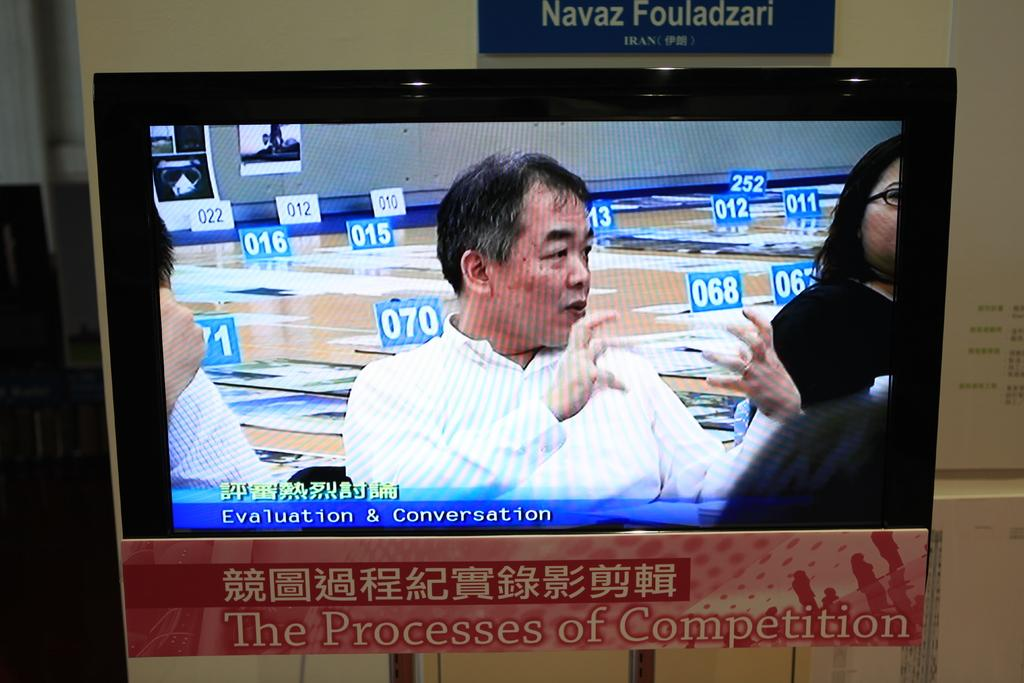<image>
Provide a brief description of the given image. A TV screen showing people talking sits above a sign that says "the process of competition." 